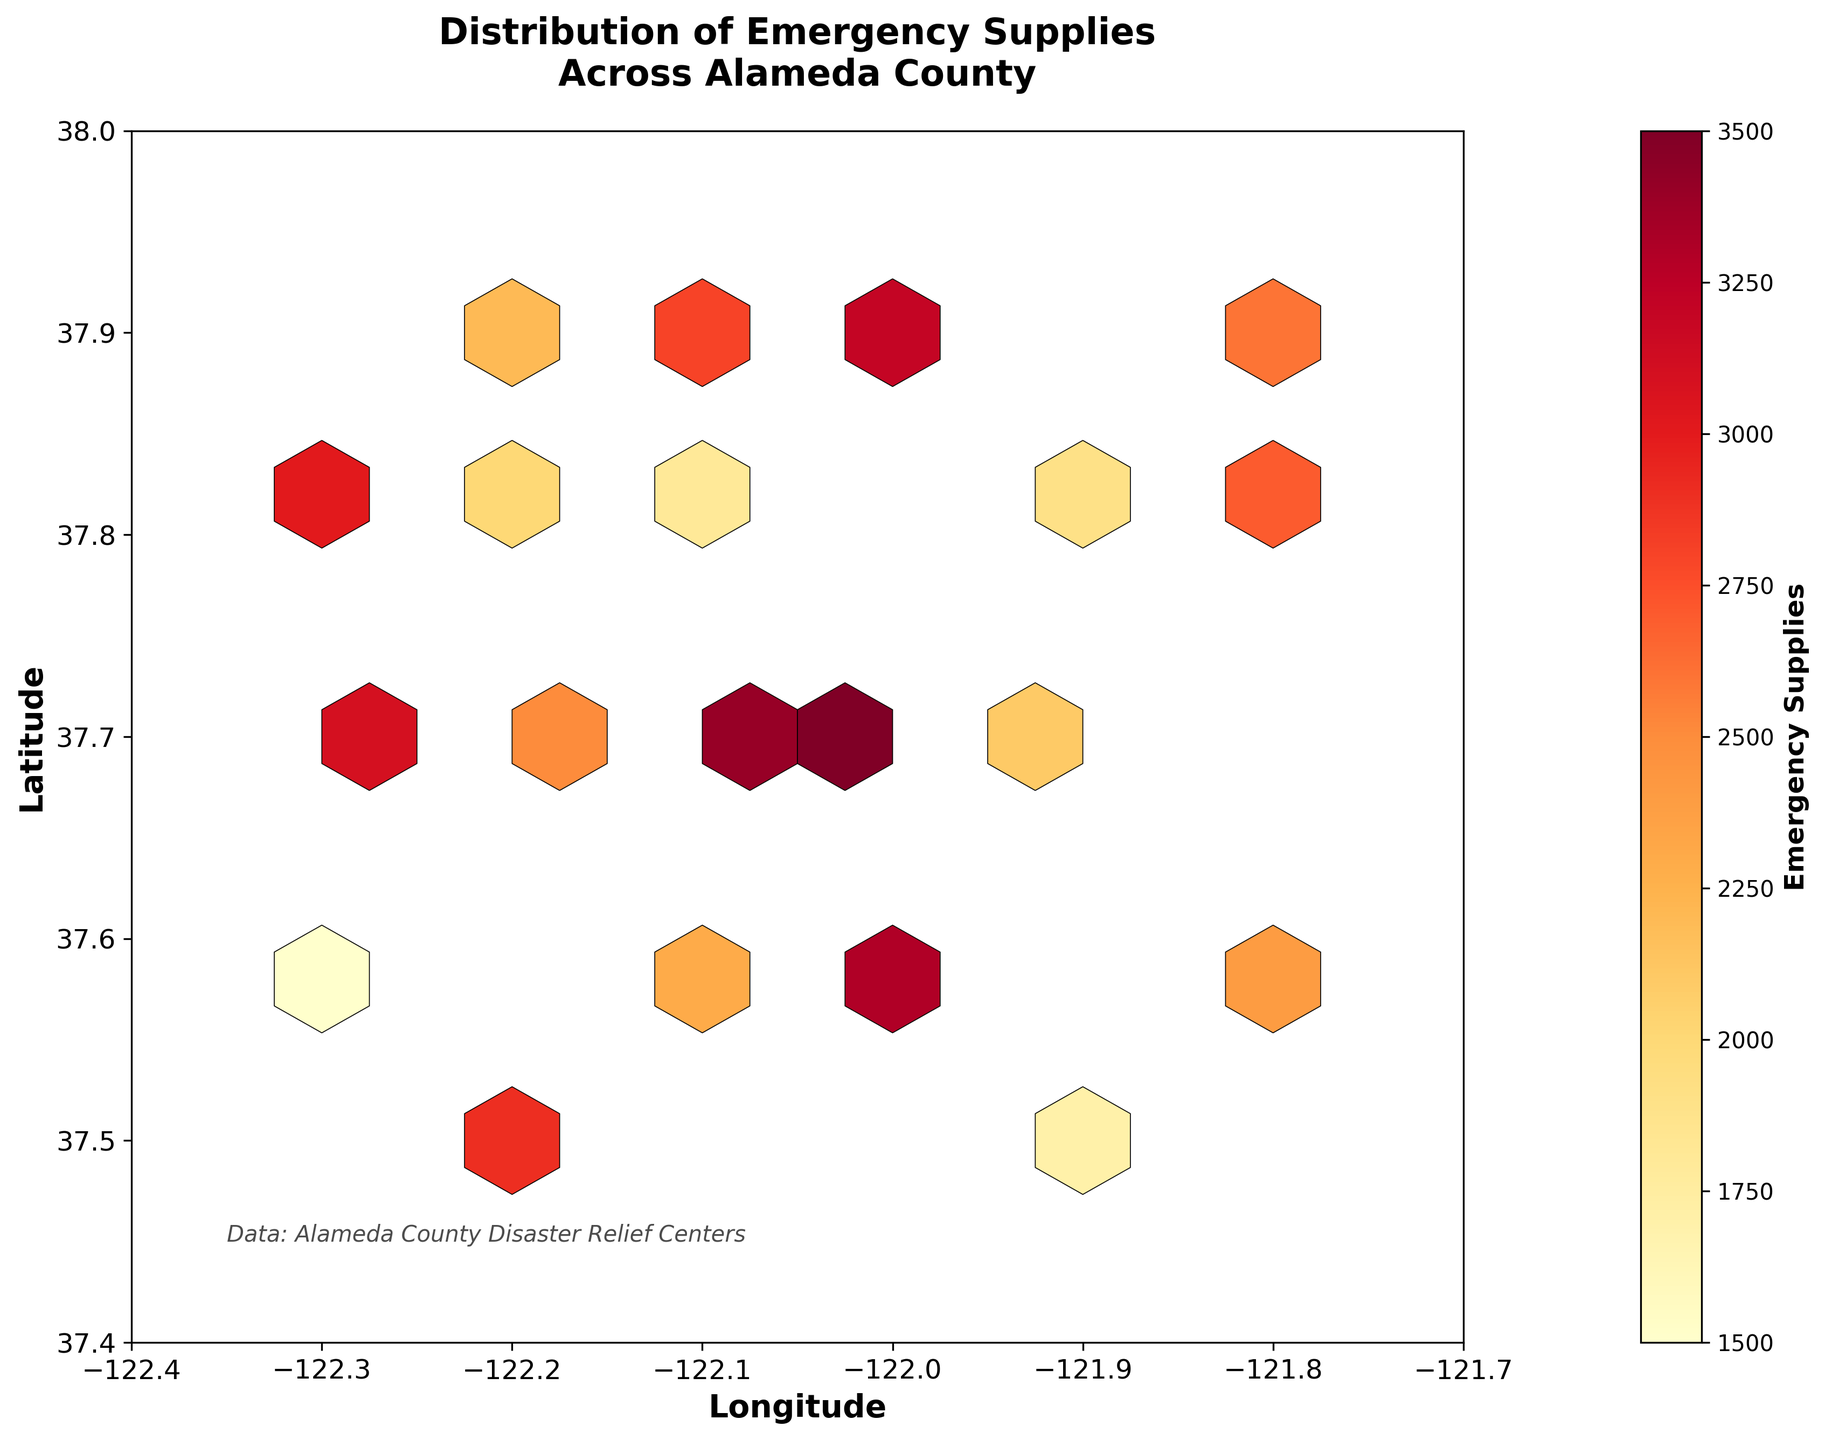What's the title of the plot? The title of the plot is displayed at the top of the figure.
Answer: Distribution of Emergency Supplies Across Alameda County What are the axes labeled? The labels can be found on the horizontal and vertical axes.
Answer: Longitude (horizontal), Latitude (vertical) What range of values does the color bar represent for emergency supplies? The color bar on the right side of the figure shows the range of values it represents.
Answer: 1500 to 3500 supplies Which area has the highest concentration of emergency supplies? From the hexbin plot, the area with the most intense color represents the highest concentration of emergency supplies. This can be interpreted from the color scale as the darker shades.
Answer: Near -122.0 longitude and 37.7 latitude How many grid areas contain the highest range of emergency supplies (i.e., closest to 3500)? To answer, locate the grid areas where the colors correspond to the highest end of the color bar. Count these areas.
Answer: 1 Which area has a higher distribution of emergency supplies: around -121.8 longitude and 37.8 latitude or around -122.0 longitude and 37.8 latitude? Compare the color intensity between the specified areas. The darker the shade, the higher the amount of supplies.
Answer: -122.0 longitudinal area Is there any significant difference in distribution between the northernmost and southernmost parts of the region? Evaluate the color intensity and the number of bins activated in the northern part (latitude near 37.9) versus the southern part (latitude near 37.5).
Answer: Yes, there's more distribution in the northern part What can be inferred about the central region of the plot, particularly around -122.2 longitude and 37.7 latitude? Observe the color intensity and the distribution in the central region. The central region seems to have varying shades, indicating differing amounts of supplies.
Answer: Varied distribution with medium to high supplies Comparing the eastern and western parts, which side shows a greater distribution of emergency supplies? Compare the overall color density/intensity of the hexes on the left part of the plot (western) versus the right part (eastern). Evaluate the vibrant shades correlating to higher values.
Answer: Eastern side 